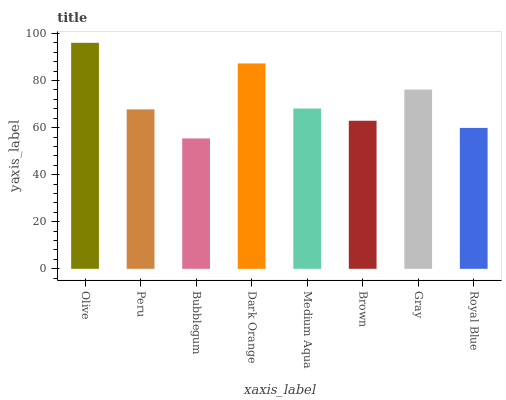Is Peru the minimum?
Answer yes or no. No. Is Peru the maximum?
Answer yes or no. No. Is Olive greater than Peru?
Answer yes or no. Yes. Is Peru less than Olive?
Answer yes or no. Yes. Is Peru greater than Olive?
Answer yes or no. No. Is Olive less than Peru?
Answer yes or no. No. Is Medium Aqua the high median?
Answer yes or no. Yes. Is Peru the low median?
Answer yes or no. Yes. Is Peru the high median?
Answer yes or no. No. Is Dark Orange the low median?
Answer yes or no. No. 